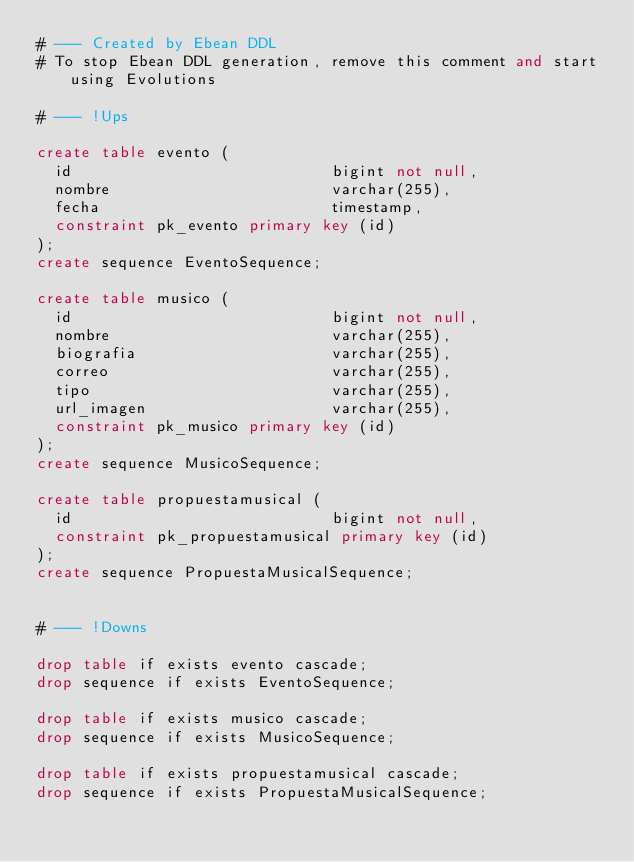<code> <loc_0><loc_0><loc_500><loc_500><_SQL_># --- Created by Ebean DDL
# To stop Ebean DDL generation, remove this comment and start using Evolutions

# --- !Ups

create table evento (
  id                            bigint not null,
  nombre                        varchar(255),
  fecha                         timestamp,
  constraint pk_evento primary key (id)
);
create sequence EventoSequence;

create table musico (
  id                            bigint not null,
  nombre                        varchar(255),
  biografia                     varchar(255),
  correo                        varchar(255),
  tipo                          varchar(255),
  url_imagen                    varchar(255),
  constraint pk_musico primary key (id)
);
create sequence MusicoSequence;

create table propuestamusical (
  id                            bigint not null,
  constraint pk_propuestamusical primary key (id)
);
create sequence PropuestaMusicalSequence;


# --- !Downs

drop table if exists evento cascade;
drop sequence if exists EventoSequence;

drop table if exists musico cascade;
drop sequence if exists MusicoSequence;

drop table if exists propuestamusical cascade;
drop sequence if exists PropuestaMusicalSequence;

</code> 